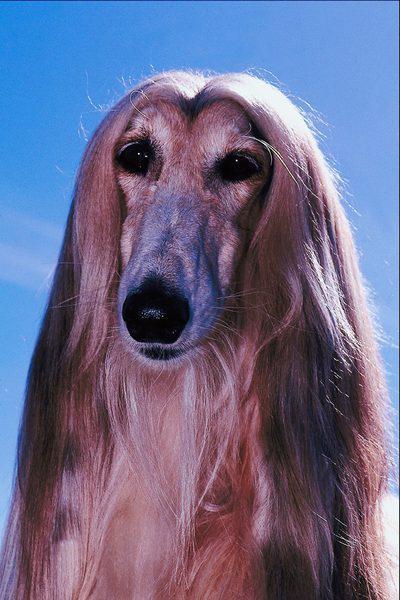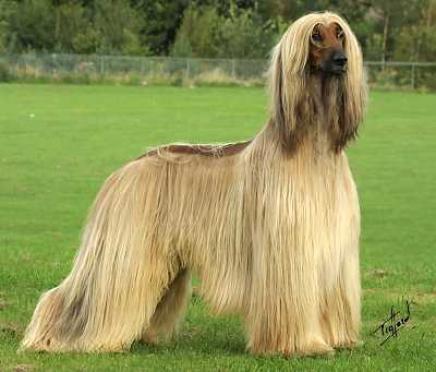The first image is the image on the left, the second image is the image on the right. Given the left and right images, does the statement "One dog is standing on all fours, and the other dog is reclining with raised head and outstretched front paws on the grass." hold true? Answer yes or no. No. 